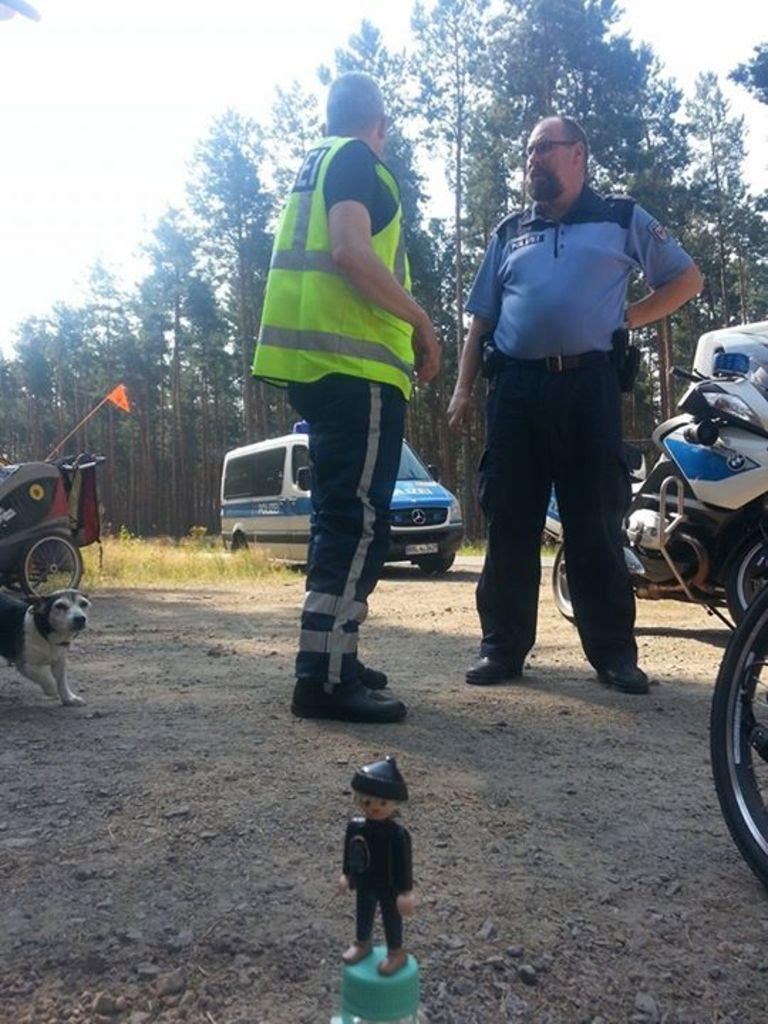What can be seen in the image? There are people standing in the image, along with a dog on the left side, vehicles, a figurine at the bottom, and trees and the sky in the background. Can you describe the dog in the image? The dog is on the left side of the image. What type of objects are the vehicles in the image? The vehicles in the image are not specified, but they are visible. What is the figurine at the bottom of the image? The figurine is present at the bottom of the image, but its specific details are not mentioned. What can be seen in the background of the image? Trees and the sky are visible in the background of the image. How do the cattle contribute to the image? There are no cattle present in the image. What type of clothing is being washed in the image? There is no washing or clothing visible in the image. 